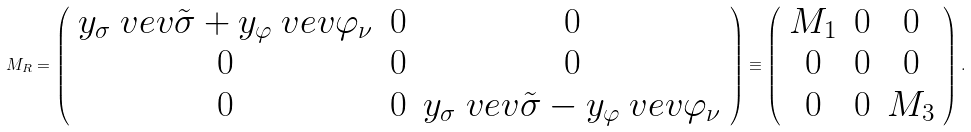<formula> <loc_0><loc_0><loc_500><loc_500>M _ { R } = \left ( \begin{array} { c c c } y _ { \sigma } \ v e v { \tilde { \sigma } } + y _ { \varphi } \ v e v { \varphi _ { \nu } } & 0 & 0 \\ 0 & 0 & 0 \\ 0 & 0 & y _ { \sigma } \ v e v { \tilde { \sigma } } - y _ { \varphi } \ v e v { \varphi _ { \nu } } \\ \end{array} \right ) \equiv \left ( \begin{array} { c c c } M _ { 1 } & 0 & 0 \\ 0 & 0 & 0 \\ 0 & 0 & M _ { 3 } \end{array} \right ) .</formula> 